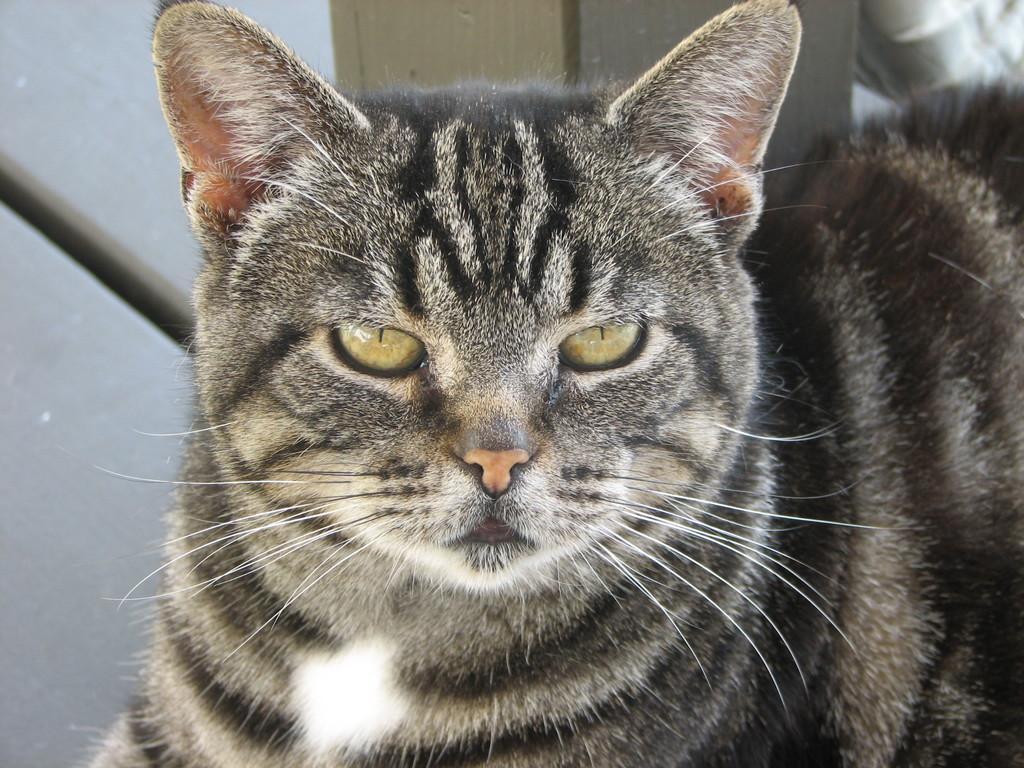Can you describe this image briefly? In this image I can see the cat which is in white and black color. I can see the whiskers to the cat. In the background I can see the surface. 